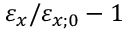<formula> <loc_0><loc_0><loc_500><loc_500>\varepsilon _ { x } / \varepsilon _ { x ; 0 } - 1</formula> 